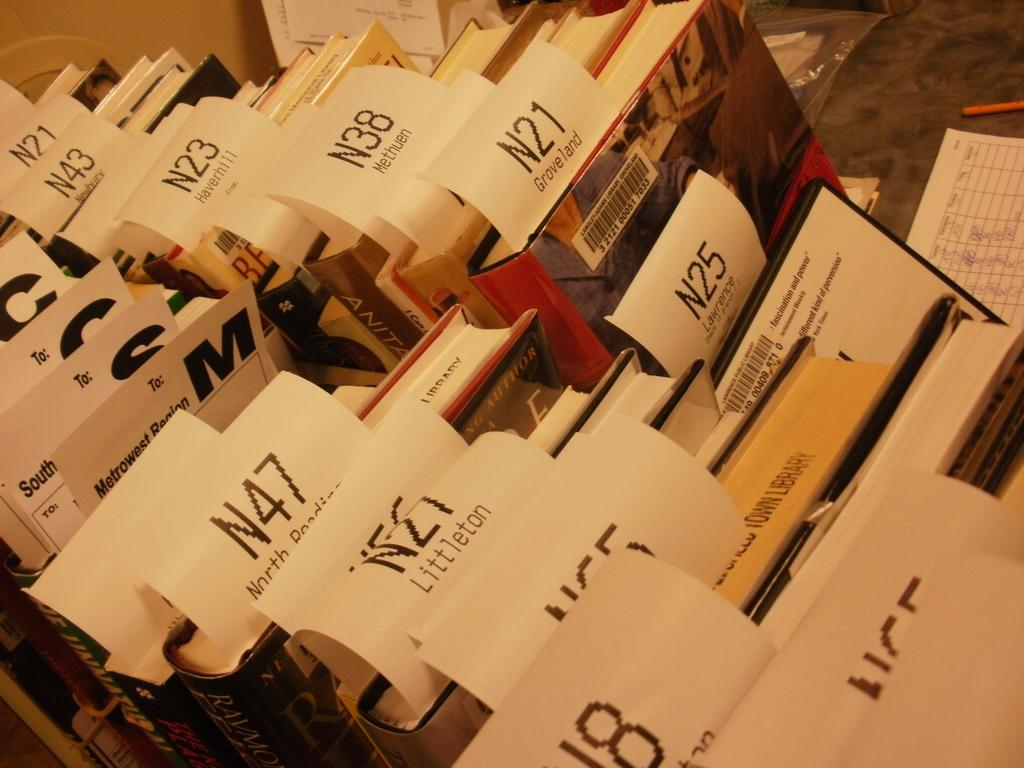<image>
Relay a brief, clear account of the picture shown. Books with receipts with the letter N and numbers. 